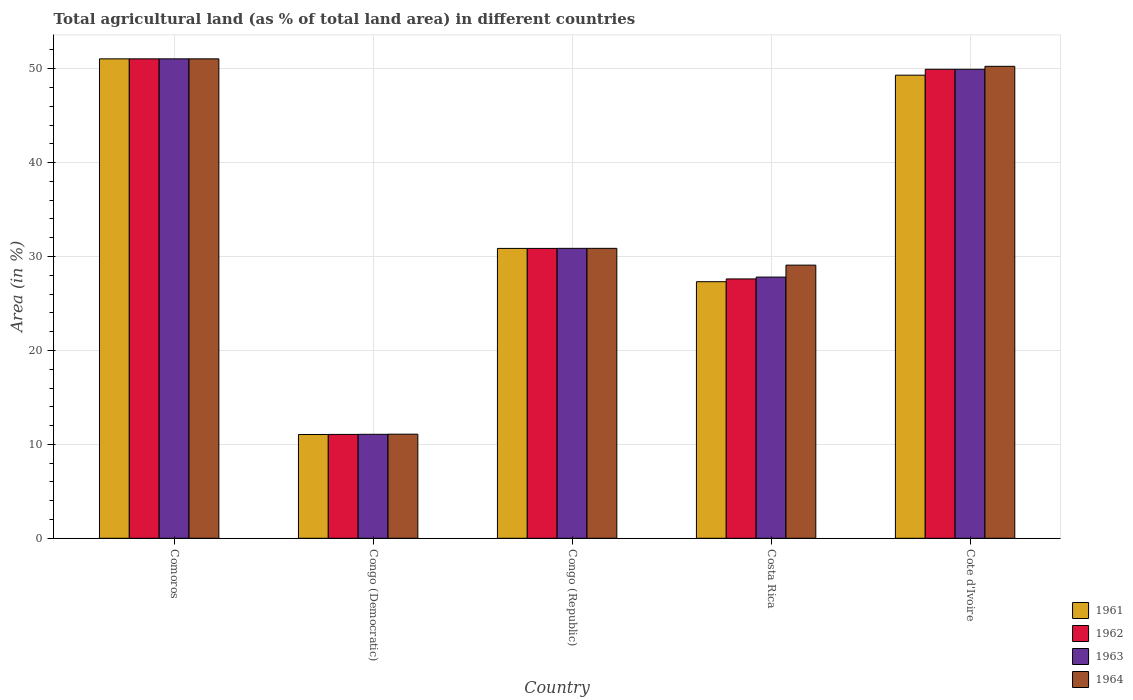Are the number of bars per tick equal to the number of legend labels?
Give a very brief answer. Yes. Are the number of bars on each tick of the X-axis equal?
Give a very brief answer. Yes. What is the label of the 5th group of bars from the left?
Provide a short and direct response. Cote d'Ivoire. In how many cases, is the number of bars for a given country not equal to the number of legend labels?
Your response must be concise. 0. What is the percentage of agricultural land in 1961 in Cote d'Ivoire?
Provide a succinct answer. 49.31. Across all countries, what is the maximum percentage of agricultural land in 1964?
Offer a very short reply. 51.05. Across all countries, what is the minimum percentage of agricultural land in 1962?
Provide a succinct answer. 11.06. In which country was the percentage of agricultural land in 1962 maximum?
Keep it short and to the point. Comoros. In which country was the percentage of agricultural land in 1964 minimum?
Your answer should be compact. Congo (Democratic). What is the total percentage of agricultural land in 1964 in the graph?
Your response must be concise. 172.34. What is the difference between the percentage of agricultural land in 1962 in Congo (Democratic) and that in Congo (Republic)?
Your answer should be compact. -19.81. What is the difference between the percentage of agricultural land in 1961 in Congo (Democratic) and the percentage of agricultural land in 1962 in Cote d'Ivoire?
Provide a short and direct response. -38.89. What is the average percentage of agricultural land in 1964 per country?
Your answer should be compact. 34.47. What is the difference between the percentage of agricultural land of/in 1961 and percentage of agricultural land of/in 1964 in Cote d'Ivoire?
Your answer should be compact. -0.94. What is the ratio of the percentage of agricultural land in 1961 in Congo (Democratic) to that in Costa Rica?
Give a very brief answer. 0.4. What is the difference between the highest and the second highest percentage of agricultural land in 1963?
Make the answer very short. -1.11. What is the difference between the highest and the lowest percentage of agricultural land in 1962?
Ensure brevity in your answer.  39.99. What does the 2nd bar from the left in Congo (Republic) represents?
Give a very brief answer. 1962. What does the 3rd bar from the right in Congo (Democratic) represents?
Offer a very short reply. 1962. Are the values on the major ticks of Y-axis written in scientific E-notation?
Your response must be concise. No. How many legend labels are there?
Your answer should be very brief. 4. How are the legend labels stacked?
Offer a terse response. Vertical. What is the title of the graph?
Your answer should be very brief. Total agricultural land (as % of total land area) in different countries. What is the label or title of the X-axis?
Give a very brief answer. Country. What is the label or title of the Y-axis?
Make the answer very short. Area (in %). What is the Area (in %) of 1961 in Comoros?
Your answer should be compact. 51.05. What is the Area (in %) of 1962 in Comoros?
Your answer should be compact. 51.05. What is the Area (in %) of 1963 in Comoros?
Give a very brief answer. 51.05. What is the Area (in %) in 1964 in Comoros?
Your response must be concise. 51.05. What is the Area (in %) of 1961 in Congo (Democratic)?
Your answer should be very brief. 11.05. What is the Area (in %) in 1962 in Congo (Democratic)?
Give a very brief answer. 11.06. What is the Area (in %) in 1963 in Congo (Democratic)?
Your answer should be compact. 11.07. What is the Area (in %) of 1964 in Congo (Democratic)?
Make the answer very short. 11.08. What is the Area (in %) in 1961 in Congo (Republic)?
Ensure brevity in your answer.  30.86. What is the Area (in %) in 1962 in Congo (Republic)?
Your answer should be very brief. 30.86. What is the Area (in %) in 1963 in Congo (Republic)?
Offer a very short reply. 30.87. What is the Area (in %) in 1964 in Congo (Republic)?
Your response must be concise. 30.87. What is the Area (in %) of 1961 in Costa Rica?
Your answer should be very brief. 27.32. What is the Area (in %) of 1962 in Costa Rica?
Your answer should be very brief. 27.61. What is the Area (in %) of 1963 in Costa Rica?
Provide a succinct answer. 27.81. What is the Area (in %) in 1964 in Costa Rica?
Make the answer very short. 29.08. What is the Area (in %) of 1961 in Cote d'Ivoire?
Offer a very short reply. 49.31. What is the Area (in %) of 1962 in Cote d'Ivoire?
Your answer should be very brief. 49.94. What is the Area (in %) in 1963 in Cote d'Ivoire?
Your answer should be very brief. 49.94. What is the Area (in %) of 1964 in Cote d'Ivoire?
Offer a very short reply. 50.25. Across all countries, what is the maximum Area (in %) of 1961?
Provide a succinct answer. 51.05. Across all countries, what is the maximum Area (in %) in 1962?
Provide a succinct answer. 51.05. Across all countries, what is the maximum Area (in %) in 1963?
Keep it short and to the point. 51.05. Across all countries, what is the maximum Area (in %) of 1964?
Provide a short and direct response. 51.05. Across all countries, what is the minimum Area (in %) of 1961?
Offer a very short reply. 11.05. Across all countries, what is the minimum Area (in %) of 1962?
Ensure brevity in your answer.  11.06. Across all countries, what is the minimum Area (in %) in 1963?
Offer a very short reply. 11.07. Across all countries, what is the minimum Area (in %) of 1964?
Keep it short and to the point. 11.08. What is the total Area (in %) of 1961 in the graph?
Ensure brevity in your answer.  169.59. What is the total Area (in %) of 1962 in the graph?
Offer a very short reply. 170.52. What is the total Area (in %) of 1963 in the graph?
Ensure brevity in your answer.  170.74. What is the total Area (in %) of 1964 in the graph?
Provide a short and direct response. 172.34. What is the difference between the Area (in %) of 1961 in Comoros and that in Congo (Democratic)?
Provide a short and direct response. 40. What is the difference between the Area (in %) of 1962 in Comoros and that in Congo (Democratic)?
Make the answer very short. 39.99. What is the difference between the Area (in %) in 1963 in Comoros and that in Congo (Democratic)?
Your response must be concise. 39.98. What is the difference between the Area (in %) of 1964 in Comoros and that in Congo (Democratic)?
Make the answer very short. 39.96. What is the difference between the Area (in %) of 1961 in Comoros and that in Congo (Republic)?
Give a very brief answer. 20.18. What is the difference between the Area (in %) in 1962 in Comoros and that in Congo (Republic)?
Provide a succinct answer. 20.18. What is the difference between the Area (in %) of 1963 in Comoros and that in Congo (Republic)?
Your answer should be compact. 20.18. What is the difference between the Area (in %) of 1964 in Comoros and that in Congo (Republic)?
Offer a very short reply. 20.18. What is the difference between the Area (in %) of 1961 in Comoros and that in Costa Rica?
Give a very brief answer. 23.73. What is the difference between the Area (in %) in 1962 in Comoros and that in Costa Rica?
Make the answer very short. 23.43. What is the difference between the Area (in %) of 1963 in Comoros and that in Costa Rica?
Give a very brief answer. 23.24. What is the difference between the Area (in %) of 1964 in Comoros and that in Costa Rica?
Your response must be concise. 21.96. What is the difference between the Area (in %) of 1961 in Comoros and that in Cote d'Ivoire?
Keep it short and to the point. 1.74. What is the difference between the Area (in %) in 1962 in Comoros and that in Cote d'Ivoire?
Offer a terse response. 1.11. What is the difference between the Area (in %) in 1963 in Comoros and that in Cote d'Ivoire?
Provide a short and direct response. 1.11. What is the difference between the Area (in %) of 1964 in Comoros and that in Cote d'Ivoire?
Provide a succinct answer. 0.8. What is the difference between the Area (in %) in 1961 in Congo (Democratic) and that in Congo (Republic)?
Make the answer very short. -19.81. What is the difference between the Area (in %) of 1962 in Congo (Democratic) and that in Congo (Republic)?
Give a very brief answer. -19.81. What is the difference between the Area (in %) in 1963 in Congo (Democratic) and that in Congo (Republic)?
Ensure brevity in your answer.  -19.8. What is the difference between the Area (in %) of 1964 in Congo (Democratic) and that in Congo (Republic)?
Offer a very short reply. -19.79. What is the difference between the Area (in %) in 1961 in Congo (Democratic) and that in Costa Rica?
Give a very brief answer. -16.27. What is the difference between the Area (in %) of 1962 in Congo (Democratic) and that in Costa Rica?
Give a very brief answer. -16.56. What is the difference between the Area (in %) in 1963 in Congo (Democratic) and that in Costa Rica?
Your answer should be compact. -16.74. What is the difference between the Area (in %) in 1964 in Congo (Democratic) and that in Costa Rica?
Your answer should be very brief. -18. What is the difference between the Area (in %) of 1961 in Congo (Democratic) and that in Cote d'Ivoire?
Provide a short and direct response. -38.26. What is the difference between the Area (in %) in 1962 in Congo (Democratic) and that in Cote d'Ivoire?
Your answer should be compact. -38.88. What is the difference between the Area (in %) of 1963 in Congo (Democratic) and that in Cote d'Ivoire?
Provide a short and direct response. -38.87. What is the difference between the Area (in %) in 1964 in Congo (Democratic) and that in Cote d'Ivoire?
Give a very brief answer. -39.17. What is the difference between the Area (in %) of 1961 in Congo (Republic) and that in Costa Rica?
Provide a succinct answer. 3.54. What is the difference between the Area (in %) in 1962 in Congo (Republic) and that in Costa Rica?
Provide a short and direct response. 3.25. What is the difference between the Area (in %) of 1963 in Congo (Republic) and that in Costa Rica?
Provide a short and direct response. 3.06. What is the difference between the Area (in %) in 1964 in Congo (Republic) and that in Costa Rica?
Your answer should be compact. 1.79. What is the difference between the Area (in %) of 1961 in Congo (Republic) and that in Cote d'Ivoire?
Provide a short and direct response. -18.44. What is the difference between the Area (in %) of 1962 in Congo (Republic) and that in Cote d'Ivoire?
Give a very brief answer. -19.07. What is the difference between the Area (in %) in 1963 in Congo (Republic) and that in Cote d'Ivoire?
Provide a short and direct response. -19.07. What is the difference between the Area (in %) in 1964 in Congo (Republic) and that in Cote d'Ivoire?
Your answer should be very brief. -19.38. What is the difference between the Area (in %) in 1961 in Costa Rica and that in Cote d'Ivoire?
Provide a short and direct response. -21.99. What is the difference between the Area (in %) of 1962 in Costa Rica and that in Cote d'Ivoire?
Offer a very short reply. -22.32. What is the difference between the Area (in %) in 1963 in Costa Rica and that in Cote d'Ivoire?
Ensure brevity in your answer.  -22.13. What is the difference between the Area (in %) of 1964 in Costa Rica and that in Cote d'Ivoire?
Offer a terse response. -21.17. What is the difference between the Area (in %) in 1961 in Comoros and the Area (in %) in 1962 in Congo (Democratic)?
Make the answer very short. 39.99. What is the difference between the Area (in %) of 1961 in Comoros and the Area (in %) of 1963 in Congo (Democratic)?
Your answer should be compact. 39.98. What is the difference between the Area (in %) in 1961 in Comoros and the Area (in %) in 1964 in Congo (Democratic)?
Keep it short and to the point. 39.96. What is the difference between the Area (in %) of 1962 in Comoros and the Area (in %) of 1963 in Congo (Democratic)?
Your answer should be very brief. 39.98. What is the difference between the Area (in %) of 1962 in Comoros and the Area (in %) of 1964 in Congo (Democratic)?
Give a very brief answer. 39.96. What is the difference between the Area (in %) of 1963 in Comoros and the Area (in %) of 1964 in Congo (Democratic)?
Give a very brief answer. 39.96. What is the difference between the Area (in %) in 1961 in Comoros and the Area (in %) in 1962 in Congo (Republic)?
Give a very brief answer. 20.18. What is the difference between the Area (in %) of 1961 in Comoros and the Area (in %) of 1963 in Congo (Republic)?
Provide a succinct answer. 20.18. What is the difference between the Area (in %) in 1961 in Comoros and the Area (in %) in 1964 in Congo (Republic)?
Make the answer very short. 20.18. What is the difference between the Area (in %) of 1962 in Comoros and the Area (in %) of 1963 in Congo (Republic)?
Provide a short and direct response. 20.18. What is the difference between the Area (in %) in 1962 in Comoros and the Area (in %) in 1964 in Congo (Republic)?
Offer a very short reply. 20.18. What is the difference between the Area (in %) in 1963 in Comoros and the Area (in %) in 1964 in Congo (Republic)?
Give a very brief answer. 20.18. What is the difference between the Area (in %) in 1961 in Comoros and the Area (in %) in 1962 in Costa Rica?
Your answer should be compact. 23.43. What is the difference between the Area (in %) of 1961 in Comoros and the Area (in %) of 1963 in Costa Rica?
Provide a short and direct response. 23.24. What is the difference between the Area (in %) of 1961 in Comoros and the Area (in %) of 1964 in Costa Rica?
Provide a short and direct response. 21.96. What is the difference between the Area (in %) of 1962 in Comoros and the Area (in %) of 1963 in Costa Rica?
Make the answer very short. 23.24. What is the difference between the Area (in %) of 1962 in Comoros and the Area (in %) of 1964 in Costa Rica?
Give a very brief answer. 21.96. What is the difference between the Area (in %) of 1963 in Comoros and the Area (in %) of 1964 in Costa Rica?
Offer a terse response. 21.96. What is the difference between the Area (in %) in 1961 in Comoros and the Area (in %) in 1962 in Cote d'Ivoire?
Offer a terse response. 1.11. What is the difference between the Area (in %) of 1961 in Comoros and the Area (in %) of 1963 in Cote d'Ivoire?
Your response must be concise. 1.11. What is the difference between the Area (in %) in 1961 in Comoros and the Area (in %) in 1964 in Cote d'Ivoire?
Offer a very short reply. 0.8. What is the difference between the Area (in %) in 1962 in Comoros and the Area (in %) in 1963 in Cote d'Ivoire?
Your answer should be compact. 1.11. What is the difference between the Area (in %) of 1962 in Comoros and the Area (in %) of 1964 in Cote d'Ivoire?
Make the answer very short. 0.8. What is the difference between the Area (in %) of 1963 in Comoros and the Area (in %) of 1964 in Cote d'Ivoire?
Make the answer very short. 0.8. What is the difference between the Area (in %) of 1961 in Congo (Democratic) and the Area (in %) of 1962 in Congo (Republic)?
Provide a short and direct response. -19.81. What is the difference between the Area (in %) in 1961 in Congo (Democratic) and the Area (in %) in 1963 in Congo (Republic)?
Make the answer very short. -19.82. What is the difference between the Area (in %) of 1961 in Congo (Democratic) and the Area (in %) of 1964 in Congo (Republic)?
Keep it short and to the point. -19.82. What is the difference between the Area (in %) in 1962 in Congo (Democratic) and the Area (in %) in 1963 in Congo (Republic)?
Your response must be concise. -19.81. What is the difference between the Area (in %) of 1962 in Congo (Democratic) and the Area (in %) of 1964 in Congo (Republic)?
Ensure brevity in your answer.  -19.81. What is the difference between the Area (in %) in 1963 in Congo (Democratic) and the Area (in %) in 1964 in Congo (Republic)?
Make the answer very short. -19.8. What is the difference between the Area (in %) in 1961 in Congo (Democratic) and the Area (in %) in 1962 in Costa Rica?
Your answer should be compact. -16.57. What is the difference between the Area (in %) of 1961 in Congo (Democratic) and the Area (in %) of 1963 in Costa Rica?
Provide a succinct answer. -16.76. What is the difference between the Area (in %) of 1961 in Congo (Democratic) and the Area (in %) of 1964 in Costa Rica?
Ensure brevity in your answer.  -18.03. What is the difference between the Area (in %) of 1962 in Congo (Democratic) and the Area (in %) of 1963 in Costa Rica?
Give a very brief answer. -16.75. What is the difference between the Area (in %) in 1962 in Congo (Democratic) and the Area (in %) in 1964 in Costa Rica?
Ensure brevity in your answer.  -18.02. What is the difference between the Area (in %) in 1963 in Congo (Democratic) and the Area (in %) in 1964 in Costa Rica?
Provide a succinct answer. -18.01. What is the difference between the Area (in %) in 1961 in Congo (Democratic) and the Area (in %) in 1962 in Cote d'Ivoire?
Your response must be concise. -38.89. What is the difference between the Area (in %) in 1961 in Congo (Democratic) and the Area (in %) in 1963 in Cote d'Ivoire?
Keep it short and to the point. -38.89. What is the difference between the Area (in %) of 1961 in Congo (Democratic) and the Area (in %) of 1964 in Cote d'Ivoire?
Your answer should be very brief. -39.2. What is the difference between the Area (in %) of 1962 in Congo (Democratic) and the Area (in %) of 1963 in Cote d'Ivoire?
Provide a short and direct response. -38.88. What is the difference between the Area (in %) of 1962 in Congo (Democratic) and the Area (in %) of 1964 in Cote d'Ivoire?
Give a very brief answer. -39.19. What is the difference between the Area (in %) in 1963 in Congo (Democratic) and the Area (in %) in 1964 in Cote d'Ivoire?
Offer a very short reply. -39.18. What is the difference between the Area (in %) in 1961 in Congo (Republic) and the Area (in %) in 1962 in Costa Rica?
Your response must be concise. 3.25. What is the difference between the Area (in %) of 1961 in Congo (Republic) and the Area (in %) of 1963 in Costa Rica?
Your answer should be very brief. 3.05. What is the difference between the Area (in %) of 1961 in Congo (Republic) and the Area (in %) of 1964 in Costa Rica?
Your response must be concise. 1.78. What is the difference between the Area (in %) in 1962 in Congo (Republic) and the Area (in %) in 1963 in Costa Rica?
Provide a succinct answer. 3.05. What is the difference between the Area (in %) in 1962 in Congo (Republic) and the Area (in %) in 1964 in Costa Rica?
Make the answer very short. 1.78. What is the difference between the Area (in %) of 1963 in Congo (Republic) and the Area (in %) of 1964 in Costa Rica?
Make the answer very short. 1.79. What is the difference between the Area (in %) in 1961 in Congo (Republic) and the Area (in %) in 1962 in Cote d'Ivoire?
Your answer should be very brief. -19.07. What is the difference between the Area (in %) of 1961 in Congo (Republic) and the Area (in %) of 1963 in Cote d'Ivoire?
Offer a terse response. -19.07. What is the difference between the Area (in %) of 1961 in Congo (Republic) and the Area (in %) of 1964 in Cote d'Ivoire?
Give a very brief answer. -19.39. What is the difference between the Area (in %) in 1962 in Congo (Republic) and the Area (in %) in 1963 in Cote d'Ivoire?
Offer a terse response. -19.07. What is the difference between the Area (in %) in 1962 in Congo (Republic) and the Area (in %) in 1964 in Cote d'Ivoire?
Your answer should be compact. -19.39. What is the difference between the Area (in %) in 1963 in Congo (Republic) and the Area (in %) in 1964 in Cote d'Ivoire?
Offer a very short reply. -19.38. What is the difference between the Area (in %) in 1961 in Costa Rica and the Area (in %) in 1962 in Cote d'Ivoire?
Make the answer very short. -22.62. What is the difference between the Area (in %) of 1961 in Costa Rica and the Area (in %) of 1963 in Cote d'Ivoire?
Make the answer very short. -22.62. What is the difference between the Area (in %) in 1961 in Costa Rica and the Area (in %) in 1964 in Cote d'Ivoire?
Provide a short and direct response. -22.93. What is the difference between the Area (in %) of 1962 in Costa Rica and the Area (in %) of 1963 in Cote d'Ivoire?
Your answer should be compact. -22.32. What is the difference between the Area (in %) of 1962 in Costa Rica and the Area (in %) of 1964 in Cote d'Ivoire?
Your answer should be very brief. -22.64. What is the difference between the Area (in %) in 1963 in Costa Rica and the Area (in %) in 1964 in Cote d'Ivoire?
Your answer should be very brief. -22.44. What is the average Area (in %) of 1961 per country?
Offer a terse response. 33.92. What is the average Area (in %) in 1962 per country?
Your answer should be very brief. 34.1. What is the average Area (in %) of 1963 per country?
Your answer should be very brief. 34.15. What is the average Area (in %) in 1964 per country?
Your response must be concise. 34.47. What is the difference between the Area (in %) in 1961 and Area (in %) in 1963 in Comoros?
Provide a short and direct response. 0. What is the difference between the Area (in %) in 1962 and Area (in %) in 1963 in Comoros?
Give a very brief answer. 0. What is the difference between the Area (in %) of 1961 and Area (in %) of 1962 in Congo (Democratic)?
Give a very brief answer. -0.01. What is the difference between the Area (in %) in 1961 and Area (in %) in 1963 in Congo (Democratic)?
Keep it short and to the point. -0.02. What is the difference between the Area (in %) of 1961 and Area (in %) of 1964 in Congo (Democratic)?
Provide a short and direct response. -0.04. What is the difference between the Area (in %) in 1962 and Area (in %) in 1963 in Congo (Democratic)?
Keep it short and to the point. -0.01. What is the difference between the Area (in %) in 1962 and Area (in %) in 1964 in Congo (Democratic)?
Ensure brevity in your answer.  -0.03. What is the difference between the Area (in %) in 1963 and Area (in %) in 1964 in Congo (Democratic)?
Your answer should be compact. -0.01. What is the difference between the Area (in %) in 1961 and Area (in %) in 1962 in Congo (Republic)?
Provide a succinct answer. 0. What is the difference between the Area (in %) in 1961 and Area (in %) in 1963 in Congo (Republic)?
Provide a succinct answer. -0.01. What is the difference between the Area (in %) in 1961 and Area (in %) in 1964 in Congo (Republic)?
Keep it short and to the point. -0.01. What is the difference between the Area (in %) of 1962 and Area (in %) of 1963 in Congo (Republic)?
Your answer should be compact. -0.01. What is the difference between the Area (in %) in 1962 and Area (in %) in 1964 in Congo (Republic)?
Your response must be concise. -0.01. What is the difference between the Area (in %) of 1963 and Area (in %) of 1964 in Congo (Republic)?
Make the answer very short. -0. What is the difference between the Area (in %) of 1961 and Area (in %) of 1962 in Costa Rica?
Offer a very short reply. -0.29. What is the difference between the Area (in %) in 1961 and Area (in %) in 1963 in Costa Rica?
Your answer should be compact. -0.49. What is the difference between the Area (in %) in 1961 and Area (in %) in 1964 in Costa Rica?
Your answer should be compact. -1.76. What is the difference between the Area (in %) of 1962 and Area (in %) of 1963 in Costa Rica?
Offer a terse response. -0.2. What is the difference between the Area (in %) in 1962 and Area (in %) in 1964 in Costa Rica?
Your answer should be very brief. -1.47. What is the difference between the Area (in %) in 1963 and Area (in %) in 1964 in Costa Rica?
Your response must be concise. -1.27. What is the difference between the Area (in %) of 1961 and Area (in %) of 1962 in Cote d'Ivoire?
Provide a succinct answer. -0.63. What is the difference between the Area (in %) in 1961 and Area (in %) in 1963 in Cote d'Ivoire?
Offer a very short reply. -0.63. What is the difference between the Area (in %) of 1961 and Area (in %) of 1964 in Cote d'Ivoire?
Ensure brevity in your answer.  -0.94. What is the difference between the Area (in %) of 1962 and Area (in %) of 1964 in Cote d'Ivoire?
Offer a very short reply. -0.31. What is the difference between the Area (in %) in 1963 and Area (in %) in 1964 in Cote d'Ivoire?
Your answer should be compact. -0.31. What is the ratio of the Area (in %) of 1961 in Comoros to that in Congo (Democratic)?
Ensure brevity in your answer.  4.62. What is the ratio of the Area (in %) in 1962 in Comoros to that in Congo (Democratic)?
Provide a succinct answer. 4.62. What is the ratio of the Area (in %) in 1963 in Comoros to that in Congo (Democratic)?
Ensure brevity in your answer.  4.61. What is the ratio of the Area (in %) in 1964 in Comoros to that in Congo (Democratic)?
Provide a short and direct response. 4.61. What is the ratio of the Area (in %) of 1961 in Comoros to that in Congo (Republic)?
Make the answer very short. 1.65. What is the ratio of the Area (in %) of 1962 in Comoros to that in Congo (Republic)?
Provide a succinct answer. 1.65. What is the ratio of the Area (in %) in 1963 in Comoros to that in Congo (Republic)?
Provide a succinct answer. 1.65. What is the ratio of the Area (in %) in 1964 in Comoros to that in Congo (Republic)?
Offer a very short reply. 1.65. What is the ratio of the Area (in %) in 1961 in Comoros to that in Costa Rica?
Your answer should be very brief. 1.87. What is the ratio of the Area (in %) of 1962 in Comoros to that in Costa Rica?
Your response must be concise. 1.85. What is the ratio of the Area (in %) in 1963 in Comoros to that in Costa Rica?
Provide a succinct answer. 1.84. What is the ratio of the Area (in %) of 1964 in Comoros to that in Costa Rica?
Provide a short and direct response. 1.76. What is the ratio of the Area (in %) of 1961 in Comoros to that in Cote d'Ivoire?
Your response must be concise. 1.04. What is the ratio of the Area (in %) in 1962 in Comoros to that in Cote d'Ivoire?
Ensure brevity in your answer.  1.02. What is the ratio of the Area (in %) in 1963 in Comoros to that in Cote d'Ivoire?
Ensure brevity in your answer.  1.02. What is the ratio of the Area (in %) in 1964 in Comoros to that in Cote d'Ivoire?
Ensure brevity in your answer.  1.02. What is the ratio of the Area (in %) of 1961 in Congo (Democratic) to that in Congo (Republic)?
Your answer should be compact. 0.36. What is the ratio of the Area (in %) in 1962 in Congo (Democratic) to that in Congo (Republic)?
Your answer should be very brief. 0.36. What is the ratio of the Area (in %) of 1963 in Congo (Democratic) to that in Congo (Republic)?
Your response must be concise. 0.36. What is the ratio of the Area (in %) of 1964 in Congo (Democratic) to that in Congo (Republic)?
Make the answer very short. 0.36. What is the ratio of the Area (in %) of 1961 in Congo (Democratic) to that in Costa Rica?
Keep it short and to the point. 0.4. What is the ratio of the Area (in %) of 1962 in Congo (Democratic) to that in Costa Rica?
Your response must be concise. 0.4. What is the ratio of the Area (in %) in 1963 in Congo (Democratic) to that in Costa Rica?
Keep it short and to the point. 0.4. What is the ratio of the Area (in %) of 1964 in Congo (Democratic) to that in Costa Rica?
Keep it short and to the point. 0.38. What is the ratio of the Area (in %) in 1961 in Congo (Democratic) to that in Cote d'Ivoire?
Provide a succinct answer. 0.22. What is the ratio of the Area (in %) in 1962 in Congo (Democratic) to that in Cote d'Ivoire?
Offer a terse response. 0.22. What is the ratio of the Area (in %) of 1963 in Congo (Democratic) to that in Cote d'Ivoire?
Offer a very short reply. 0.22. What is the ratio of the Area (in %) of 1964 in Congo (Democratic) to that in Cote d'Ivoire?
Provide a succinct answer. 0.22. What is the ratio of the Area (in %) in 1961 in Congo (Republic) to that in Costa Rica?
Offer a terse response. 1.13. What is the ratio of the Area (in %) of 1962 in Congo (Republic) to that in Costa Rica?
Your answer should be very brief. 1.12. What is the ratio of the Area (in %) in 1963 in Congo (Republic) to that in Costa Rica?
Provide a short and direct response. 1.11. What is the ratio of the Area (in %) of 1964 in Congo (Republic) to that in Costa Rica?
Ensure brevity in your answer.  1.06. What is the ratio of the Area (in %) in 1961 in Congo (Republic) to that in Cote d'Ivoire?
Give a very brief answer. 0.63. What is the ratio of the Area (in %) in 1962 in Congo (Republic) to that in Cote d'Ivoire?
Ensure brevity in your answer.  0.62. What is the ratio of the Area (in %) of 1963 in Congo (Republic) to that in Cote d'Ivoire?
Keep it short and to the point. 0.62. What is the ratio of the Area (in %) in 1964 in Congo (Republic) to that in Cote d'Ivoire?
Your answer should be very brief. 0.61. What is the ratio of the Area (in %) in 1961 in Costa Rica to that in Cote d'Ivoire?
Your answer should be very brief. 0.55. What is the ratio of the Area (in %) of 1962 in Costa Rica to that in Cote d'Ivoire?
Make the answer very short. 0.55. What is the ratio of the Area (in %) of 1963 in Costa Rica to that in Cote d'Ivoire?
Your answer should be compact. 0.56. What is the ratio of the Area (in %) of 1964 in Costa Rica to that in Cote d'Ivoire?
Your answer should be very brief. 0.58. What is the difference between the highest and the second highest Area (in %) of 1961?
Your answer should be compact. 1.74. What is the difference between the highest and the second highest Area (in %) in 1962?
Your response must be concise. 1.11. What is the difference between the highest and the second highest Area (in %) of 1963?
Your answer should be very brief. 1.11. What is the difference between the highest and the second highest Area (in %) of 1964?
Ensure brevity in your answer.  0.8. What is the difference between the highest and the lowest Area (in %) in 1961?
Offer a terse response. 40. What is the difference between the highest and the lowest Area (in %) in 1962?
Give a very brief answer. 39.99. What is the difference between the highest and the lowest Area (in %) of 1963?
Your answer should be compact. 39.98. What is the difference between the highest and the lowest Area (in %) in 1964?
Give a very brief answer. 39.96. 